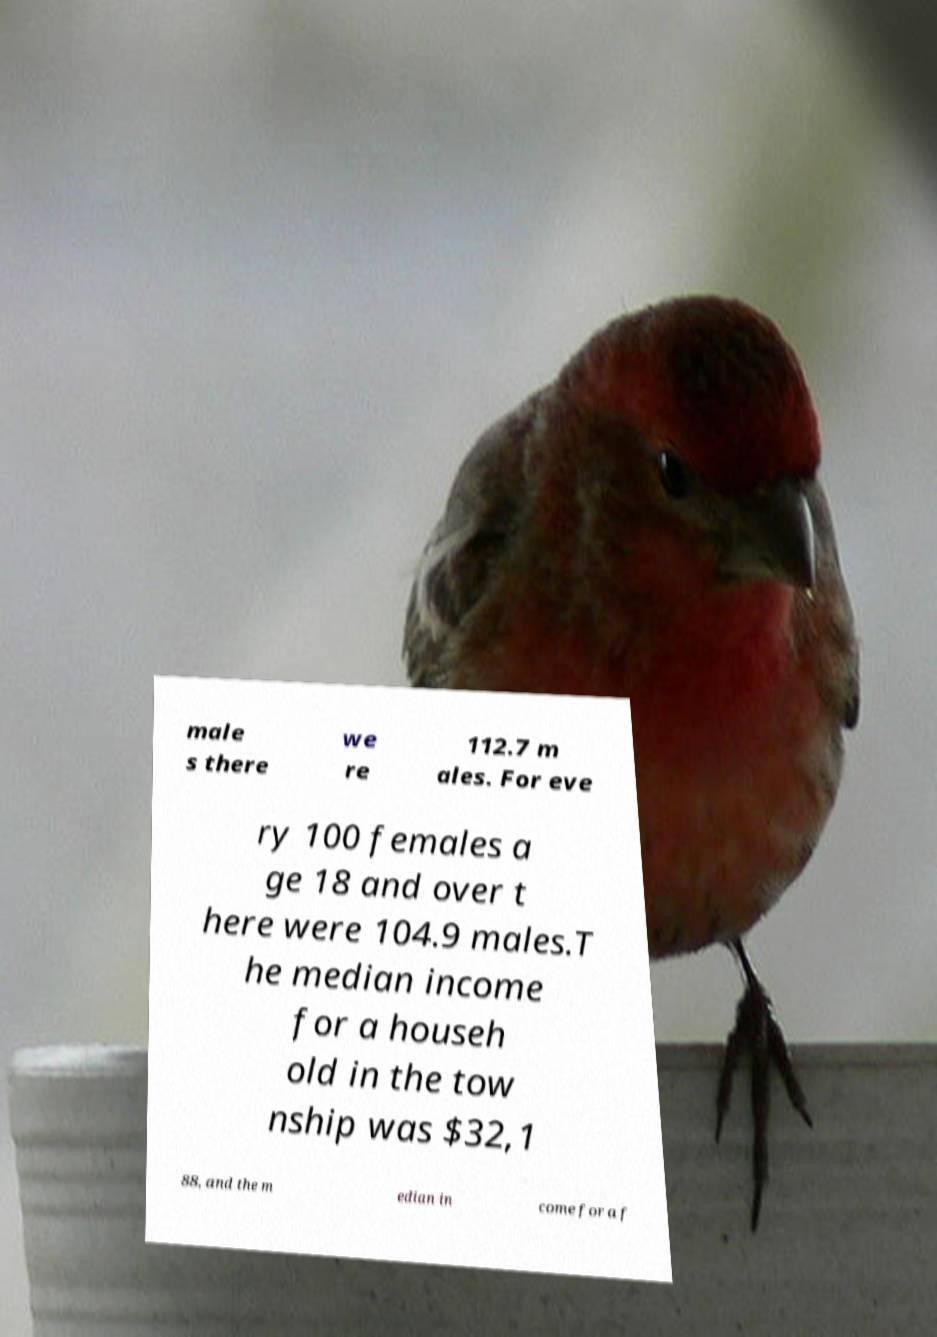Please read and relay the text visible in this image. What does it say? male s there we re 112.7 m ales. For eve ry 100 females a ge 18 and over t here were 104.9 males.T he median income for a househ old in the tow nship was $32,1 88, and the m edian in come for a f 